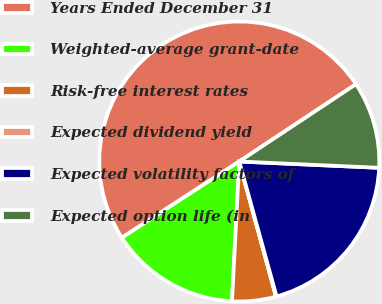Convert chart to OTSL. <chart><loc_0><loc_0><loc_500><loc_500><pie_chart><fcel>Years Ended December 31<fcel>Weighted-average grant-date<fcel>Risk-free interest rates<fcel>Expected dividend yield<fcel>Expected volatility factors of<fcel>Expected option life (in<nl><fcel>49.85%<fcel>15.01%<fcel>5.05%<fcel>0.07%<fcel>19.99%<fcel>10.03%<nl></chart> 